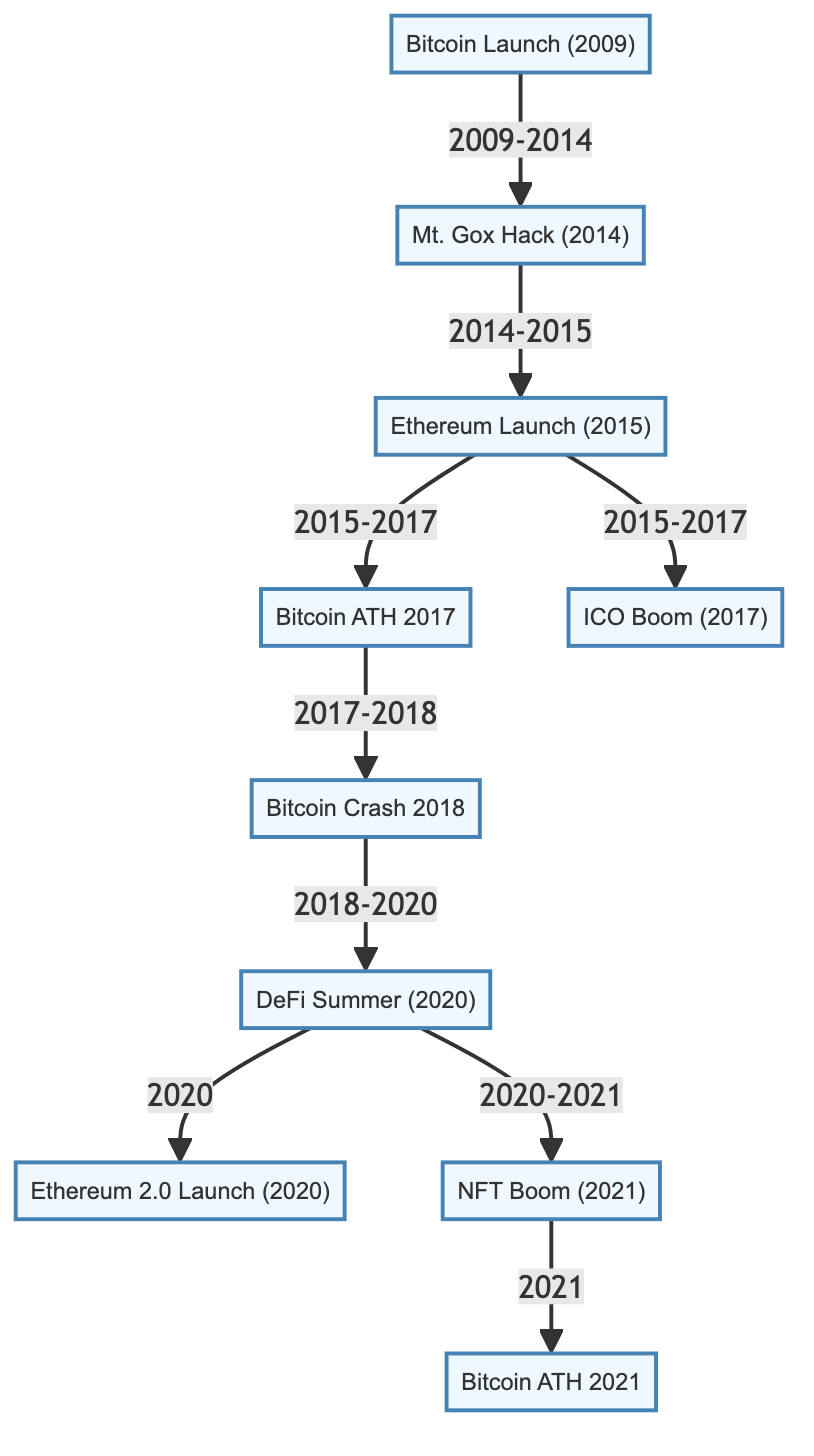what is the first event in the diagram? The diagram starts with the "Bitcoin Launch (2009)" node as the first event that initiated the cryptocurrency market timeline.
Answer: Bitcoin Launch (2009) how many total events are displayed in the diagram? By counting the nodes in the diagram, there are a total of ten major events listed that shape the historical perspective of the cryptocurrency market.
Answer: 10 which two events are directly connected by an arrow? The "Bitcoin Launch (2009)" is directly connected to the "Mt. Gox Hack (2014)" indicating the sequence of events that follow the launch.
Answer: Bitcoin Launch (2009) and Mt. Gox Hack (2014) what event follows the "DeFi Summer (2020)" in the diagram? The event that follows "DeFi Summer (2020)" according to the arrows in the diagram is "Ethereum 2.0 Launch (2020)" indicating a major development in the Ethereum network.
Answer: Ethereum 2.0 Launch (2020) which event occurs between the "Bitcoin ATH 2017" and "Bitcoin Crash 2018"? The event that occurs in between "Bitcoin ATH 2017" and "Bitcoin Crash 2018" is a direct transition showing a negative market movement from an all-time high to a crash.
Answer: Bitcoin Crash 2018 what is the relationship between "ICO Boom (2017)" and "Bitcoin ATH 2017"? The relationship shows that both events occurred in a linked timeline between 2015 and 2017, with "ICO Boom (2017)" emerging as a significant event shortly after the "Ethereum Launch (2015)".
Answer: Both occurred after Ethereum Launch which major event is shown to lead into the "NFT Boom (2021)"? The "DeFi Summer (2020)" has a direct path that leads into the "NFT Boom (2021)," indicating a continuation of growth and innovation in the crypto market.
Answer: DeFi Summer (2020) how does the diagram illustrate the impact of the "Mt. Gox Hack (2014)" on subsequent events? The arrow from "Mt. Gox Hack (2014)" to "Ethereum Launch (2015)" indicates that despite the hack, it did not halt the progression of the crypto space and instead led to the evolution of Ethereum.
Answer: It leads to Ethereum Launch what does the "Bitcoin ATH 2021" indicate in relation to previous events? "Bitcoin ATH 2021" signifies a peak in the cryptocurrency market that follows several prior events, particularly noting the influence of both "NFT Boom (2021)" and significant price movements established earlier.
Answer: A peak following several events 